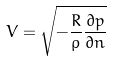Convert formula to latex. <formula><loc_0><loc_0><loc_500><loc_500>V = \sqrt { - \frac { R } { \rho } \frac { \partial p } { \partial n } }</formula> 